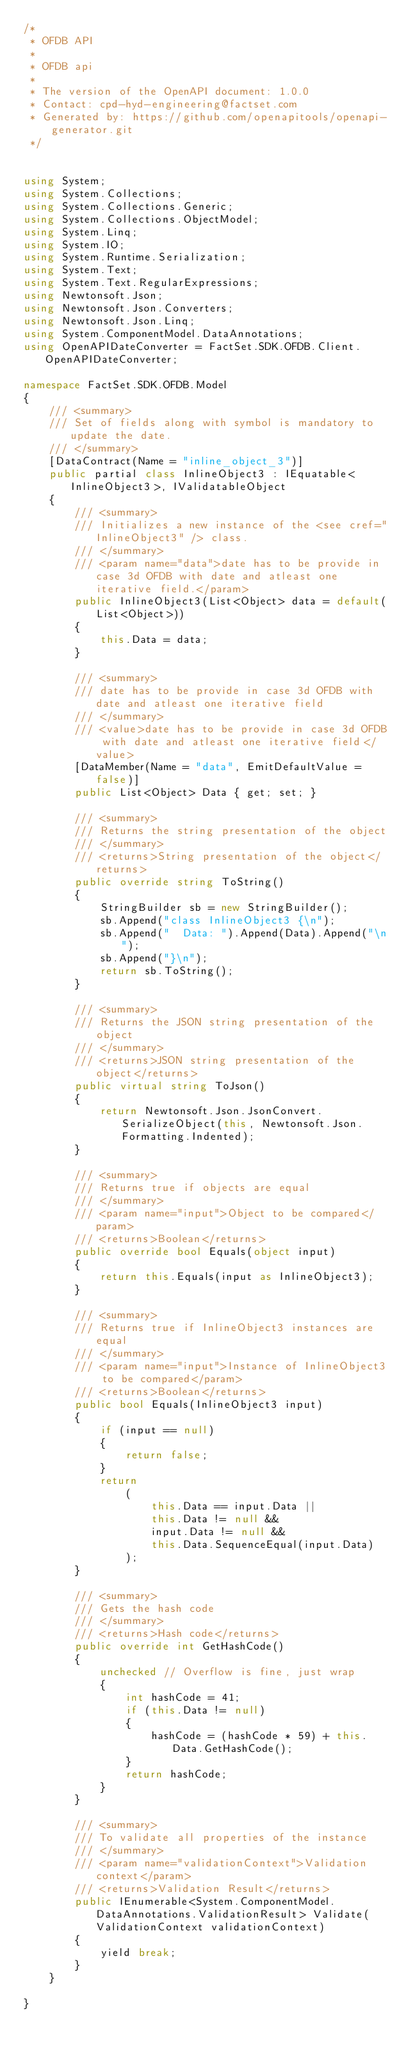<code> <loc_0><loc_0><loc_500><loc_500><_C#_>/*
 * OFDB API
 *
 * OFDB api
 *
 * The version of the OpenAPI document: 1.0.0
 * Contact: cpd-hyd-engineering@factset.com
 * Generated by: https://github.com/openapitools/openapi-generator.git
 */


using System;
using System.Collections;
using System.Collections.Generic;
using System.Collections.ObjectModel;
using System.Linq;
using System.IO;
using System.Runtime.Serialization;
using System.Text;
using System.Text.RegularExpressions;
using Newtonsoft.Json;
using Newtonsoft.Json.Converters;
using Newtonsoft.Json.Linq;
using System.ComponentModel.DataAnnotations;
using OpenAPIDateConverter = FactSet.SDK.OFDB.Client.OpenAPIDateConverter;

namespace FactSet.SDK.OFDB.Model
{
    /// <summary>
    /// Set of fields along with symbol is mandatory to update the date.
    /// </summary>
    [DataContract(Name = "inline_object_3")]
    public partial class InlineObject3 : IEquatable<InlineObject3>, IValidatableObject
    {
        /// <summary>
        /// Initializes a new instance of the <see cref="InlineObject3" /> class.
        /// </summary>
        /// <param name="data">date has to be provide in case 3d OFDB with date and atleast one iterative field.</param>
        public InlineObject3(List<Object> data = default(List<Object>))
        {
            this.Data = data;
        }

        /// <summary>
        /// date has to be provide in case 3d OFDB with date and atleast one iterative field
        /// </summary>
        /// <value>date has to be provide in case 3d OFDB with date and atleast one iterative field</value>
        [DataMember(Name = "data", EmitDefaultValue = false)]
        public List<Object> Data { get; set; }

        /// <summary>
        /// Returns the string presentation of the object
        /// </summary>
        /// <returns>String presentation of the object</returns>
        public override string ToString()
        {
            StringBuilder sb = new StringBuilder();
            sb.Append("class InlineObject3 {\n");
            sb.Append("  Data: ").Append(Data).Append("\n");
            sb.Append("}\n");
            return sb.ToString();
        }

        /// <summary>
        /// Returns the JSON string presentation of the object
        /// </summary>
        /// <returns>JSON string presentation of the object</returns>
        public virtual string ToJson()
        {
            return Newtonsoft.Json.JsonConvert.SerializeObject(this, Newtonsoft.Json.Formatting.Indented);
        }

        /// <summary>
        /// Returns true if objects are equal
        /// </summary>
        /// <param name="input">Object to be compared</param>
        /// <returns>Boolean</returns>
        public override bool Equals(object input)
        {
            return this.Equals(input as InlineObject3);
        }

        /// <summary>
        /// Returns true if InlineObject3 instances are equal
        /// </summary>
        /// <param name="input">Instance of InlineObject3 to be compared</param>
        /// <returns>Boolean</returns>
        public bool Equals(InlineObject3 input)
        {
            if (input == null)
            {
                return false;
            }
            return 
                (
                    this.Data == input.Data ||
                    this.Data != null &&
                    input.Data != null &&
                    this.Data.SequenceEqual(input.Data)
                );
        }

        /// <summary>
        /// Gets the hash code
        /// </summary>
        /// <returns>Hash code</returns>
        public override int GetHashCode()
        {
            unchecked // Overflow is fine, just wrap
            {
                int hashCode = 41;
                if (this.Data != null)
                {
                    hashCode = (hashCode * 59) + this.Data.GetHashCode();
                }
                return hashCode;
            }
        }

        /// <summary>
        /// To validate all properties of the instance
        /// </summary>
        /// <param name="validationContext">Validation context</param>
        /// <returns>Validation Result</returns>
        public IEnumerable<System.ComponentModel.DataAnnotations.ValidationResult> Validate(ValidationContext validationContext)
        {
            yield break;
        }
    }

}
</code> 